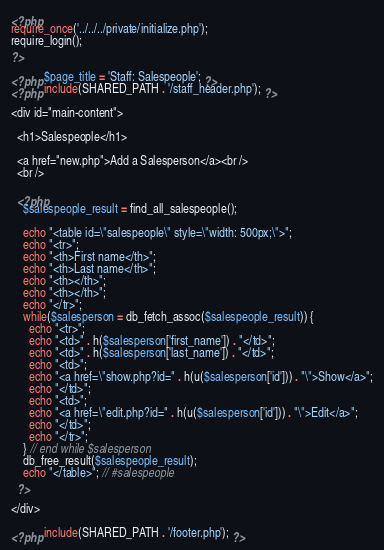<code> <loc_0><loc_0><loc_500><loc_500><_PHP_><?php
require_once('../../../private/initialize.php');
require_login();
?>

<?php $page_title = 'Staff: Salespeople'; ?>
<?php include(SHARED_PATH . '/staff_header.php'); ?>

<div id="main-content">

  <h1>Salespeople</h1>

  <a href="new.php">Add a Salesperson</a><br />
  <br />

  <?php
    $salespeople_result = find_all_salespeople();

    echo "<table id=\"salespeople\" style=\"width: 500px;\">";
    echo "<tr>";
    echo "<th>First name</th>";
    echo "<th>Last name</th>";
    echo "<th></th>";
    echo "<th></th>";
    echo "</tr>";
    while($salesperson = db_fetch_assoc($salespeople_result)) {
      echo "<tr>";
      echo "<td>" . h($salesperson['first_name']) . "</td>";
      echo "<td>" . h($salesperson['last_name']) . "</td>";
      echo "<td>";
      echo "<a href=\"show.php?id=" . h(u($salesperson['id'])) . "\">Show</a>";
      echo "</td>";
      echo "<td>";
      echo "<a href=\"edit.php?id=" . h(u($salesperson['id'])) . "\">Edit</a>";
      echo "</td>";
      echo "</tr>";
    } // end while $salesperson
    db_free_result($salespeople_result);
    echo "</table>"; // #salespeople
  ?>

</div>

<?php include(SHARED_PATH . '/footer.php'); ?>
</code> 